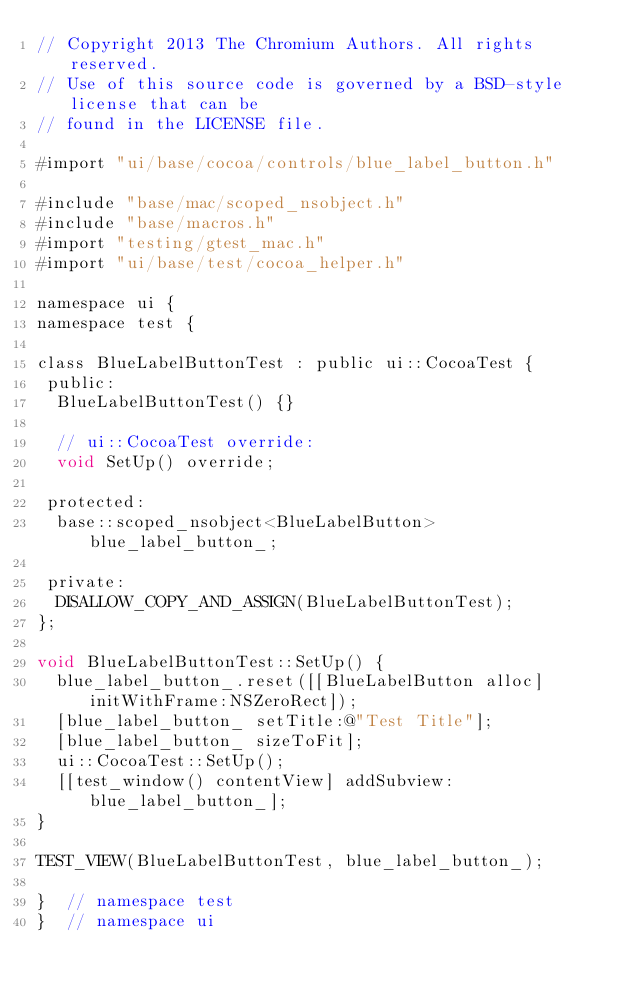<code> <loc_0><loc_0><loc_500><loc_500><_ObjectiveC_>// Copyright 2013 The Chromium Authors. All rights reserved.
// Use of this source code is governed by a BSD-style license that can be
// found in the LICENSE file.

#import "ui/base/cocoa/controls/blue_label_button.h"

#include "base/mac/scoped_nsobject.h"
#include "base/macros.h"
#import "testing/gtest_mac.h"
#import "ui/base/test/cocoa_helper.h"

namespace ui {
namespace test {

class BlueLabelButtonTest : public ui::CocoaTest {
 public:
  BlueLabelButtonTest() {}

  // ui::CocoaTest override:
  void SetUp() override;

 protected:
  base::scoped_nsobject<BlueLabelButton> blue_label_button_;

 private:
  DISALLOW_COPY_AND_ASSIGN(BlueLabelButtonTest);
};

void BlueLabelButtonTest::SetUp() {
  blue_label_button_.reset([[BlueLabelButton alloc] initWithFrame:NSZeroRect]);
  [blue_label_button_ setTitle:@"Test Title"];
  [blue_label_button_ sizeToFit];
  ui::CocoaTest::SetUp();
  [[test_window() contentView] addSubview:blue_label_button_];
}

TEST_VIEW(BlueLabelButtonTest, blue_label_button_);

}  // namespace test
}  // namespace ui
</code> 